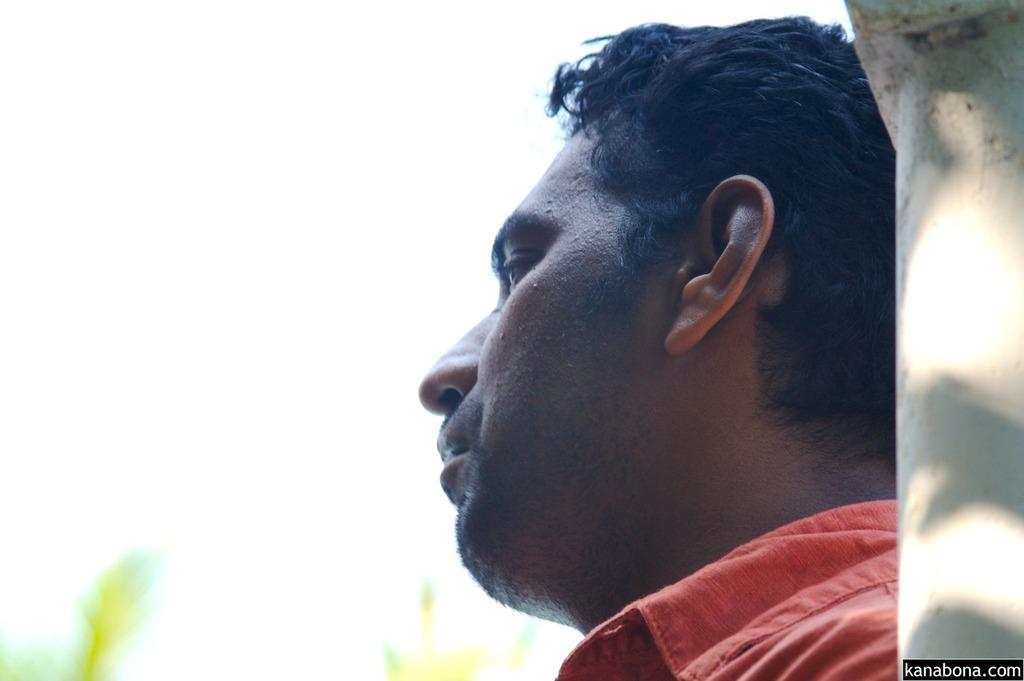What is the main subject in the image? There is a person in the image. What direction is the person looking? The person is looking to the left side of the image. What can be seen behind the person? There is a wall behind the person. How would you describe the background of the image? The background of the image is blurred. Can you see any dogs in the image? There are no dogs present in the image. What type of surprise is the person holding in the image? There is no surprise visible in the image; the person is simply looking to the left side. 